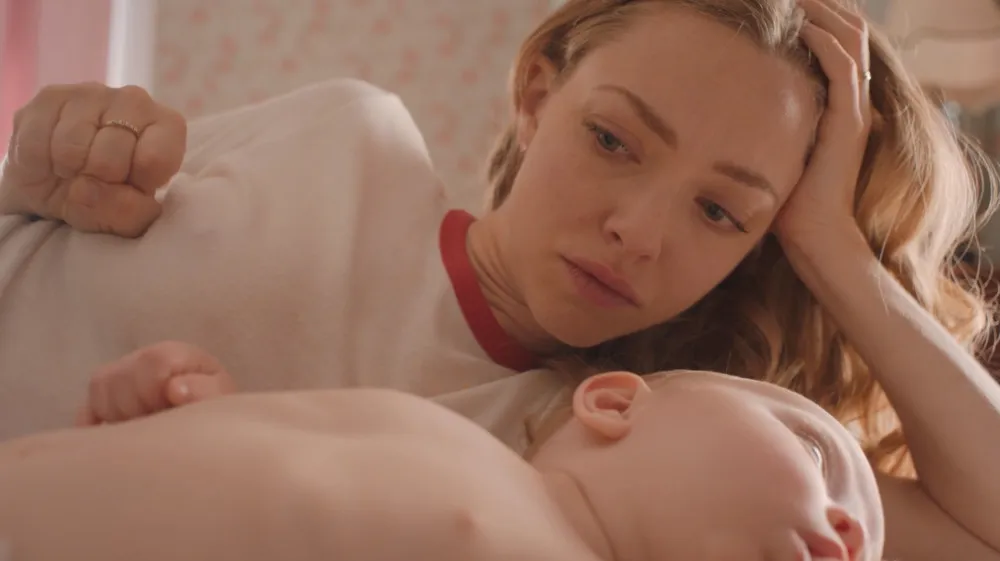How does the setting influence the overall mood of the scene? The setting of the room, with its soft pink floral wallpaper and gentle lighting, creates a warm and comforting atmosphere. It enhances the serene and peaceful mood, accentuating the quiet moment shared between the woman and the sleeping child. This setting contributes to the theme of tranquility and maternal love in the image. 